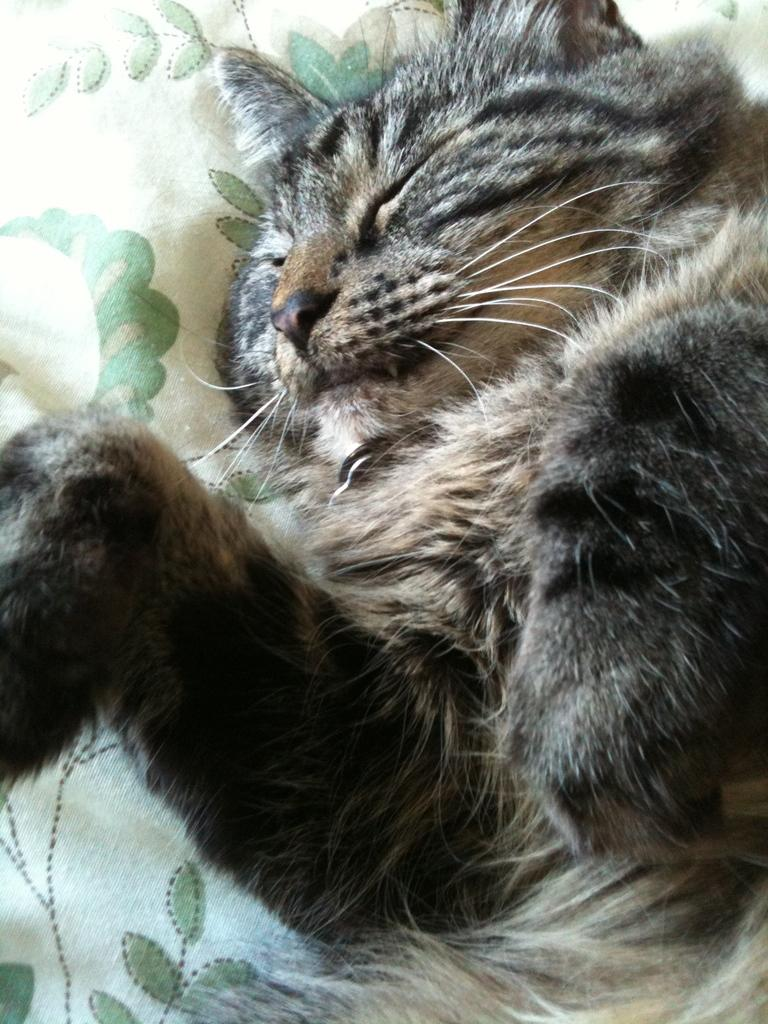What animal is present in the image? There is a cat in the image. What is the cat doing in the image? The cat is sleeping. What is the cat resting on in the image? The cat is on a cloth. How many bikes can be seen in the image? There are no bikes present in the image. What is the cat's interest in the image? The cat's interest cannot be determined from the image, as it is sleeping. 